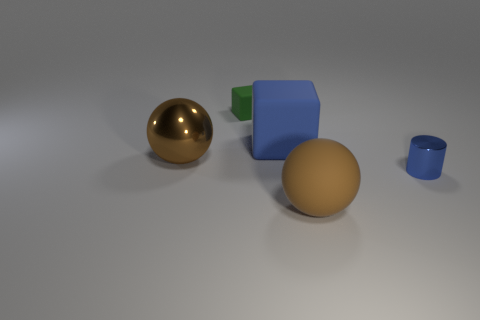Add 2 big matte blocks. How many objects exist? 7 Subtract all cubes. How many objects are left? 3 Subtract 1 blue cylinders. How many objects are left? 4 Subtract all small matte cubes. Subtract all tiny brown metallic cylinders. How many objects are left? 4 Add 5 big matte blocks. How many big matte blocks are left? 6 Add 4 small yellow metal balls. How many small yellow metal balls exist? 4 